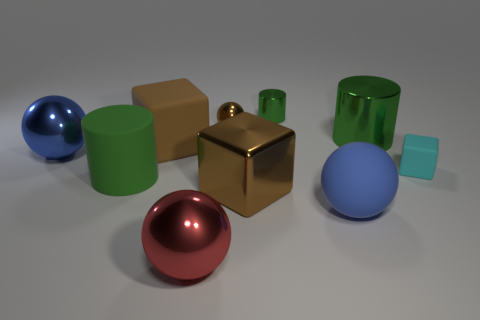What shape is the big matte thing that is the same color as the small shiny ball?
Your response must be concise. Cube. There is another sphere that is the same color as the rubber ball; what is its size?
Your answer should be compact. Large. There is a large brown block that is in front of the cylinder that is in front of the green metallic object that is in front of the tiny green cylinder; what is it made of?
Your response must be concise. Metal. The large blue object left of the green cylinder that is in front of the big shiny cylinder is what shape?
Provide a short and direct response. Sphere. Do the big cylinder that is to the right of the large red ball and the small cube have the same material?
Provide a short and direct response. No. What number of green things are big shiny cubes or tiny matte balls?
Provide a short and direct response. 0. Are there any cylinders of the same color as the matte sphere?
Keep it short and to the point. No. Are there any large blue balls made of the same material as the small cyan block?
Your answer should be very brief. Yes. What shape is the big object that is both to the left of the large brown matte cube and in front of the small rubber object?
Your answer should be very brief. Cylinder. What number of small things are blue shiny cylinders or metal spheres?
Provide a succinct answer. 1. 